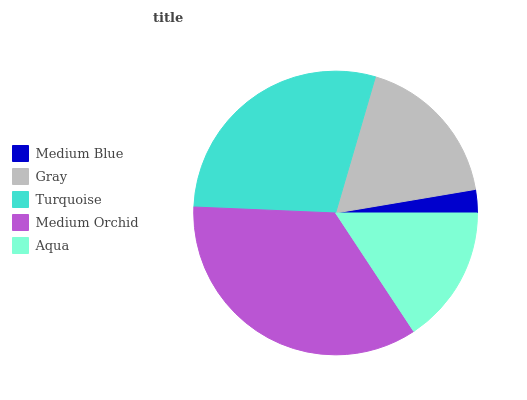Is Medium Blue the minimum?
Answer yes or no. Yes. Is Medium Orchid the maximum?
Answer yes or no. Yes. Is Gray the minimum?
Answer yes or no. No. Is Gray the maximum?
Answer yes or no. No. Is Gray greater than Medium Blue?
Answer yes or no. Yes. Is Medium Blue less than Gray?
Answer yes or no. Yes. Is Medium Blue greater than Gray?
Answer yes or no. No. Is Gray less than Medium Blue?
Answer yes or no. No. Is Gray the high median?
Answer yes or no. Yes. Is Gray the low median?
Answer yes or no. Yes. Is Medium Blue the high median?
Answer yes or no. No. Is Aqua the low median?
Answer yes or no. No. 